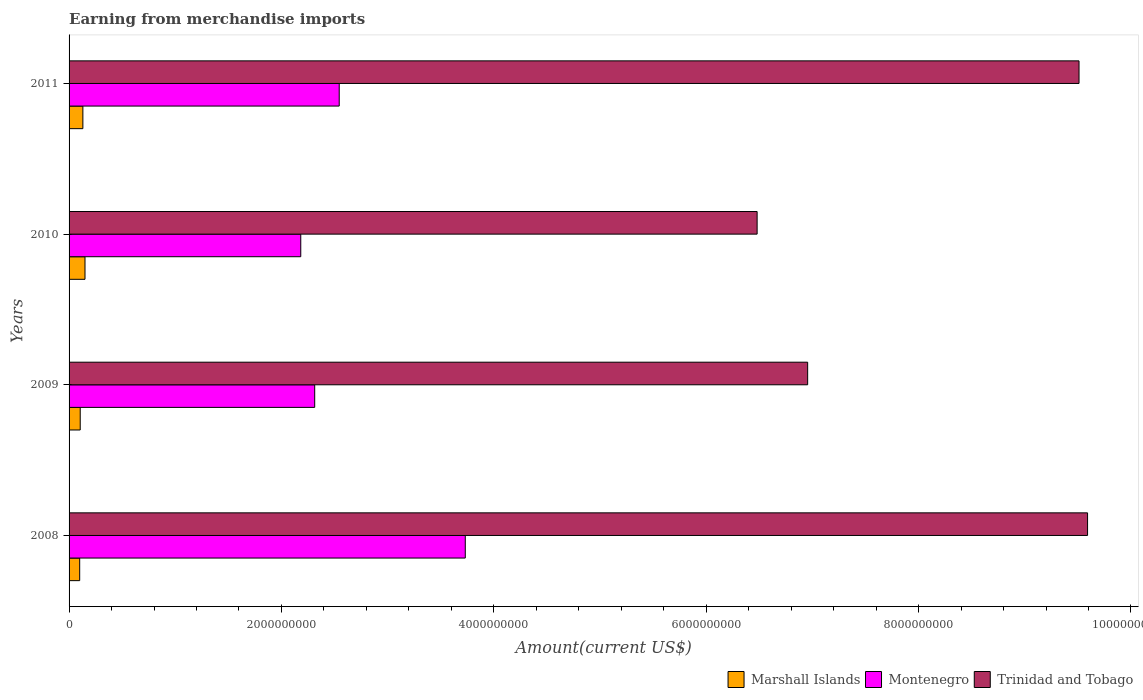How many groups of bars are there?
Offer a terse response. 4. What is the amount earned from merchandise imports in Montenegro in 2008?
Provide a succinct answer. 3.73e+09. Across all years, what is the maximum amount earned from merchandise imports in Trinidad and Tobago?
Offer a terse response. 9.59e+09. Across all years, what is the minimum amount earned from merchandise imports in Trinidad and Tobago?
Provide a succinct answer. 6.48e+09. What is the total amount earned from merchandise imports in Marshall Islands in the graph?
Offer a very short reply. 4.85e+08. What is the difference between the amount earned from merchandise imports in Montenegro in 2009 and that in 2011?
Give a very brief answer. -2.31e+08. What is the difference between the amount earned from merchandise imports in Marshall Islands in 2009 and the amount earned from merchandise imports in Trinidad and Tobago in 2011?
Offer a terse response. -9.41e+09. What is the average amount earned from merchandise imports in Montenegro per year?
Offer a terse response. 2.69e+09. In the year 2008, what is the difference between the amount earned from merchandise imports in Marshall Islands and amount earned from merchandise imports in Montenegro?
Give a very brief answer. -3.63e+09. In how many years, is the amount earned from merchandise imports in Trinidad and Tobago greater than 3600000000 US$?
Make the answer very short. 4. What is the ratio of the amount earned from merchandise imports in Trinidad and Tobago in 2009 to that in 2010?
Give a very brief answer. 1.07. Is the amount earned from merchandise imports in Marshall Islands in 2008 less than that in 2011?
Your answer should be compact. Yes. What is the difference between the highest and the second highest amount earned from merchandise imports in Montenegro?
Your answer should be very brief. 1.19e+09. What is the difference between the highest and the lowest amount earned from merchandise imports in Trinidad and Tobago?
Keep it short and to the point. 3.11e+09. In how many years, is the amount earned from merchandise imports in Trinidad and Tobago greater than the average amount earned from merchandise imports in Trinidad and Tobago taken over all years?
Give a very brief answer. 2. What does the 2nd bar from the top in 2011 represents?
Offer a terse response. Montenegro. What does the 2nd bar from the bottom in 2009 represents?
Make the answer very short. Montenegro. Is it the case that in every year, the sum of the amount earned from merchandise imports in Marshall Islands and amount earned from merchandise imports in Trinidad and Tobago is greater than the amount earned from merchandise imports in Montenegro?
Provide a succinct answer. Yes. How many bars are there?
Give a very brief answer. 12. Does the graph contain any zero values?
Make the answer very short. No. What is the title of the graph?
Your answer should be very brief. Earning from merchandise imports. Does "Chile" appear as one of the legend labels in the graph?
Offer a terse response. No. What is the label or title of the X-axis?
Offer a terse response. Amount(current US$). What is the label or title of the Y-axis?
Give a very brief answer. Years. What is the Amount(current US$) of Marshall Islands in 2008?
Your answer should be compact. 1.00e+08. What is the Amount(current US$) in Montenegro in 2008?
Your answer should be compact. 3.73e+09. What is the Amount(current US$) in Trinidad and Tobago in 2008?
Ensure brevity in your answer.  9.59e+09. What is the Amount(current US$) in Marshall Islands in 2009?
Your answer should be very brief. 1.05e+08. What is the Amount(current US$) in Montenegro in 2009?
Offer a very short reply. 2.31e+09. What is the Amount(current US$) of Trinidad and Tobago in 2009?
Offer a very short reply. 6.96e+09. What is the Amount(current US$) in Marshall Islands in 2010?
Ensure brevity in your answer.  1.50e+08. What is the Amount(current US$) of Montenegro in 2010?
Your answer should be compact. 2.18e+09. What is the Amount(current US$) of Trinidad and Tobago in 2010?
Make the answer very short. 6.48e+09. What is the Amount(current US$) in Marshall Islands in 2011?
Your response must be concise. 1.30e+08. What is the Amount(current US$) in Montenegro in 2011?
Your response must be concise. 2.54e+09. What is the Amount(current US$) in Trinidad and Tobago in 2011?
Provide a short and direct response. 9.51e+09. Across all years, what is the maximum Amount(current US$) in Marshall Islands?
Make the answer very short. 1.50e+08. Across all years, what is the maximum Amount(current US$) in Montenegro?
Keep it short and to the point. 3.73e+09. Across all years, what is the maximum Amount(current US$) of Trinidad and Tobago?
Offer a terse response. 9.59e+09. Across all years, what is the minimum Amount(current US$) in Montenegro?
Offer a very short reply. 2.18e+09. Across all years, what is the minimum Amount(current US$) of Trinidad and Tobago?
Offer a terse response. 6.48e+09. What is the total Amount(current US$) of Marshall Islands in the graph?
Your answer should be very brief. 4.85e+08. What is the total Amount(current US$) in Montenegro in the graph?
Your response must be concise. 1.08e+1. What is the total Amount(current US$) in Trinidad and Tobago in the graph?
Your answer should be compact. 3.25e+1. What is the difference between the Amount(current US$) of Marshall Islands in 2008 and that in 2009?
Provide a succinct answer. -5.00e+06. What is the difference between the Amount(current US$) of Montenegro in 2008 and that in 2009?
Ensure brevity in your answer.  1.42e+09. What is the difference between the Amount(current US$) of Trinidad and Tobago in 2008 and that in 2009?
Give a very brief answer. 2.64e+09. What is the difference between the Amount(current US$) in Marshall Islands in 2008 and that in 2010?
Your response must be concise. -5.00e+07. What is the difference between the Amount(current US$) of Montenegro in 2008 and that in 2010?
Offer a terse response. 1.55e+09. What is the difference between the Amount(current US$) in Trinidad and Tobago in 2008 and that in 2010?
Ensure brevity in your answer.  3.11e+09. What is the difference between the Amount(current US$) in Marshall Islands in 2008 and that in 2011?
Make the answer very short. -3.00e+07. What is the difference between the Amount(current US$) of Montenegro in 2008 and that in 2011?
Make the answer very short. 1.19e+09. What is the difference between the Amount(current US$) in Trinidad and Tobago in 2008 and that in 2011?
Keep it short and to the point. 8.05e+07. What is the difference between the Amount(current US$) in Marshall Islands in 2009 and that in 2010?
Ensure brevity in your answer.  -4.50e+07. What is the difference between the Amount(current US$) of Montenegro in 2009 and that in 2010?
Keep it short and to the point. 1.31e+08. What is the difference between the Amount(current US$) in Trinidad and Tobago in 2009 and that in 2010?
Your answer should be very brief. 4.76e+08. What is the difference between the Amount(current US$) of Marshall Islands in 2009 and that in 2011?
Provide a succinct answer. -2.50e+07. What is the difference between the Amount(current US$) in Montenegro in 2009 and that in 2011?
Your response must be concise. -2.31e+08. What is the difference between the Amount(current US$) of Trinidad and Tobago in 2009 and that in 2011?
Ensure brevity in your answer.  -2.56e+09. What is the difference between the Amount(current US$) in Montenegro in 2010 and that in 2011?
Your response must be concise. -3.62e+08. What is the difference between the Amount(current US$) of Trinidad and Tobago in 2010 and that in 2011?
Ensure brevity in your answer.  -3.03e+09. What is the difference between the Amount(current US$) of Marshall Islands in 2008 and the Amount(current US$) of Montenegro in 2009?
Ensure brevity in your answer.  -2.21e+09. What is the difference between the Amount(current US$) of Marshall Islands in 2008 and the Amount(current US$) of Trinidad and Tobago in 2009?
Offer a terse response. -6.86e+09. What is the difference between the Amount(current US$) of Montenegro in 2008 and the Amount(current US$) of Trinidad and Tobago in 2009?
Your answer should be very brief. -3.22e+09. What is the difference between the Amount(current US$) in Marshall Islands in 2008 and the Amount(current US$) in Montenegro in 2010?
Offer a terse response. -2.08e+09. What is the difference between the Amount(current US$) in Marshall Islands in 2008 and the Amount(current US$) in Trinidad and Tobago in 2010?
Offer a very short reply. -6.38e+09. What is the difference between the Amount(current US$) of Montenegro in 2008 and the Amount(current US$) of Trinidad and Tobago in 2010?
Your answer should be very brief. -2.75e+09. What is the difference between the Amount(current US$) in Marshall Islands in 2008 and the Amount(current US$) in Montenegro in 2011?
Make the answer very short. -2.44e+09. What is the difference between the Amount(current US$) of Marshall Islands in 2008 and the Amount(current US$) of Trinidad and Tobago in 2011?
Give a very brief answer. -9.41e+09. What is the difference between the Amount(current US$) in Montenegro in 2008 and the Amount(current US$) in Trinidad and Tobago in 2011?
Your response must be concise. -5.78e+09. What is the difference between the Amount(current US$) of Marshall Islands in 2009 and the Amount(current US$) of Montenegro in 2010?
Keep it short and to the point. -2.08e+09. What is the difference between the Amount(current US$) of Marshall Islands in 2009 and the Amount(current US$) of Trinidad and Tobago in 2010?
Ensure brevity in your answer.  -6.37e+09. What is the difference between the Amount(current US$) of Montenegro in 2009 and the Amount(current US$) of Trinidad and Tobago in 2010?
Your response must be concise. -4.17e+09. What is the difference between the Amount(current US$) of Marshall Islands in 2009 and the Amount(current US$) of Montenegro in 2011?
Your response must be concise. -2.44e+09. What is the difference between the Amount(current US$) of Marshall Islands in 2009 and the Amount(current US$) of Trinidad and Tobago in 2011?
Offer a very short reply. -9.41e+09. What is the difference between the Amount(current US$) of Montenegro in 2009 and the Amount(current US$) of Trinidad and Tobago in 2011?
Offer a very short reply. -7.20e+09. What is the difference between the Amount(current US$) in Marshall Islands in 2010 and the Amount(current US$) in Montenegro in 2011?
Ensure brevity in your answer.  -2.39e+09. What is the difference between the Amount(current US$) of Marshall Islands in 2010 and the Amount(current US$) of Trinidad and Tobago in 2011?
Make the answer very short. -9.36e+09. What is the difference between the Amount(current US$) in Montenegro in 2010 and the Amount(current US$) in Trinidad and Tobago in 2011?
Ensure brevity in your answer.  -7.33e+09. What is the average Amount(current US$) in Marshall Islands per year?
Offer a very short reply. 1.21e+08. What is the average Amount(current US$) of Montenegro per year?
Offer a very short reply. 2.69e+09. What is the average Amount(current US$) of Trinidad and Tobago per year?
Give a very brief answer. 8.13e+09. In the year 2008, what is the difference between the Amount(current US$) in Marshall Islands and Amount(current US$) in Montenegro?
Your response must be concise. -3.63e+09. In the year 2008, what is the difference between the Amount(current US$) of Marshall Islands and Amount(current US$) of Trinidad and Tobago?
Provide a succinct answer. -9.49e+09. In the year 2008, what is the difference between the Amount(current US$) in Montenegro and Amount(current US$) in Trinidad and Tobago?
Make the answer very short. -5.86e+09. In the year 2009, what is the difference between the Amount(current US$) of Marshall Islands and Amount(current US$) of Montenegro?
Make the answer very short. -2.21e+09. In the year 2009, what is the difference between the Amount(current US$) of Marshall Islands and Amount(current US$) of Trinidad and Tobago?
Offer a very short reply. -6.85e+09. In the year 2009, what is the difference between the Amount(current US$) in Montenegro and Amount(current US$) in Trinidad and Tobago?
Your response must be concise. -4.64e+09. In the year 2010, what is the difference between the Amount(current US$) in Marshall Islands and Amount(current US$) in Montenegro?
Your answer should be very brief. -2.03e+09. In the year 2010, what is the difference between the Amount(current US$) of Marshall Islands and Amount(current US$) of Trinidad and Tobago?
Provide a succinct answer. -6.33e+09. In the year 2010, what is the difference between the Amount(current US$) of Montenegro and Amount(current US$) of Trinidad and Tobago?
Offer a terse response. -4.30e+09. In the year 2011, what is the difference between the Amount(current US$) in Marshall Islands and Amount(current US$) in Montenegro?
Give a very brief answer. -2.41e+09. In the year 2011, what is the difference between the Amount(current US$) in Marshall Islands and Amount(current US$) in Trinidad and Tobago?
Give a very brief answer. -9.38e+09. In the year 2011, what is the difference between the Amount(current US$) in Montenegro and Amount(current US$) in Trinidad and Tobago?
Ensure brevity in your answer.  -6.97e+09. What is the ratio of the Amount(current US$) of Marshall Islands in 2008 to that in 2009?
Your response must be concise. 0.95. What is the ratio of the Amount(current US$) in Montenegro in 2008 to that in 2009?
Make the answer very short. 1.61. What is the ratio of the Amount(current US$) of Trinidad and Tobago in 2008 to that in 2009?
Give a very brief answer. 1.38. What is the ratio of the Amount(current US$) of Montenegro in 2008 to that in 2010?
Offer a very short reply. 1.71. What is the ratio of the Amount(current US$) in Trinidad and Tobago in 2008 to that in 2010?
Ensure brevity in your answer.  1.48. What is the ratio of the Amount(current US$) of Marshall Islands in 2008 to that in 2011?
Offer a very short reply. 0.77. What is the ratio of the Amount(current US$) of Montenegro in 2008 to that in 2011?
Make the answer very short. 1.47. What is the ratio of the Amount(current US$) in Trinidad and Tobago in 2008 to that in 2011?
Provide a succinct answer. 1.01. What is the ratio of the Amount(current US$) of Montenegro in 2009 to that in 2010?
Offer a terse response. 1.06. What is the ratio of the Amount(current US$) of Trinidad and Tobago in 2009 to that in 2010?
Your answer should be compact. 1.07. What is the ratio of the Amount(current US$) in Marshall Islands in 2009 to that in 2011?
Your response must be concise. 0.81. What is the ratio of the Amount(current US$) of Montenegro in 2009 to that in 2011?
Give a very brief answer. 0.91. What is the ratio of the Amount(current US$) of Trinidad and Tobago in 2009 to that in 2011?
Provide a short and direct response. 0.73. What is the ratio of the Amount(current US$) in Marshall Islands in 2010 to that in 2011?
Offer a terse response. 1.15. What is the ratio of the Amount(current US$) of Montenegro in 2010 to that in 2011?
Make the answer very short. 0.86. What is the ratio of the Amount(current US$) in Trinidad and Tobago in 2010 to that in 2011?
Ensure brevity in your answer.  0.68. What is the difference between the highest and the second highest Amount(current US$) of Montenegro?
Offer a very short reply. 1.19e+09. What is the difference between the highest and the second highest Amount(current US$) in Trinidad and Tobago?
Keep it short and to the point. 8.05e+07. What is the difference between the highest and the lowest Amount(current US$) in Marshall Islands?
Keep it short and to the point. 5.00e+07. What is the difference between the highest and the lowest Amount(current US$) of Montenegro?
Provide a succinct answer. 1.55e+09. What is the difference between the highest and the lowest Amount(current US$) in Trinidad and Tobago?
Your answer should be very brief. 3.11e+09. 